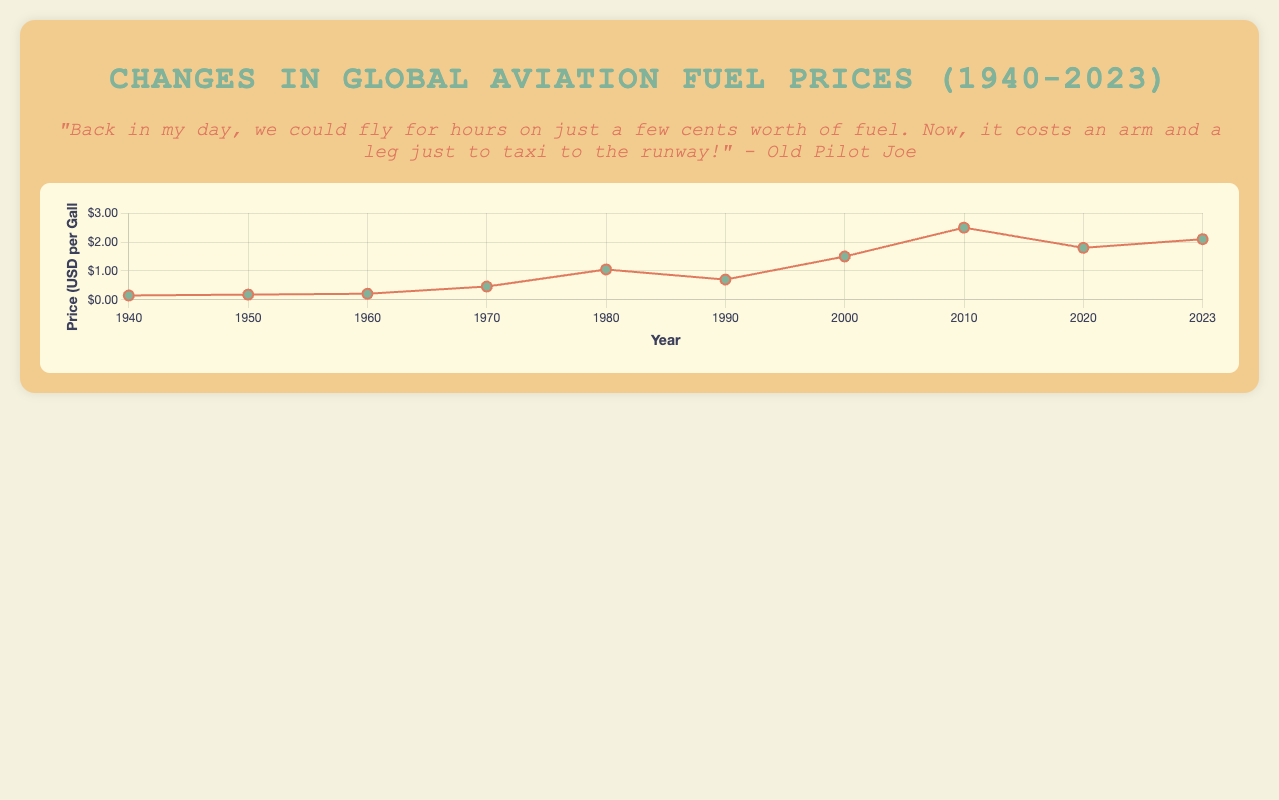What's the highest fuel price recorded on the chart? Observing the plotted points on the line graph, we see that in 2010, the fuel price peaked at $2.50 per gallon.
Answer: $2.50 per gallon Which major event is associated with the steepest increase in fuel prices? Comparing the slopes between data points, the steepest rise in fuel price occurred between 1970 and 1980, associated with the Oil Crisis where the price jumped from $0.21 to $0.46 per gallon.
Answer: Oil Crisis During which decade did aviation fuel prices drop the most after a previous spike? Looking at consecutive drops in the line plot, the largest drop is from 2000 to 2010, decreasing from $1.50 to $0.70 per gallon, following the Dot-com Boom.
Answer: 2000-2010 How does the fuel price in 1990 compare with the price in 2000? Checking the graph, in 1990 the price was $0.70 per gallon, and in 2000 it was $1.50 per gallon, showing an increase.
Answer: The price in 2000 is higher What is the average fuel price between 1940 and 1950? The prices are 0.15 and 0.18 respectively. The average is calculated as (0.15 + 0.18) / 2.
Answer: $0.165 per gallon During which major event did the fuel price drop after an initial sharp rise in nearly the same time frame? After the Gulf War in the 1990s, the line shows a price drop from $0.70 in 1990 to $1.50 in 2000, then a subsequent rise.
Answer: Gulf War What was the fuel price trend during the COVID-19 Pandemic according to the plot? The chart shows a drop in fuel prices from $2.50 in 2010 to $1.80 in 2020 during the COVID-19 Pandemic.
Answer: The trend was a decline What's the percentage increase in fuel price from 1940 to 1980? The prices in 1940 and 1980 are $0.15 and $1.05, respectively. The percentage increase is ((1.05 - 0.15) / 0.15) * 100.
Answer: 600% During which event did fuel prices approximately double? Examining the graph, the fuel price nearly doubled from $0.46 in 1970 to $1.05 in 1980 around the Oil Crisis of the 1970s.
Answer: Oil Crisis 